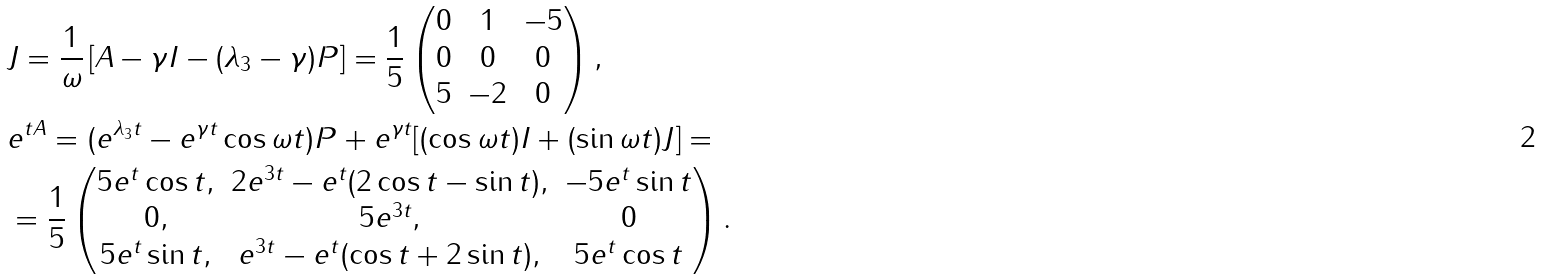<formula> <loc_0><loc_0><loc_500><loc_500>& J = \frac { 1 } { \omega } \left [ A - \gamma I - ( \lambda _ { 3 } - \gamma ) P \right ] = \frac { 1 } { 5 } \begin{pmatrix} 0 & 1 & - 5 \\ 0 & 0 & 0 \\ 5 & - 2 & 0 \end{pmatrix} , \\ & e ^ { t A } = ( e ^ { \lambda _ { 3 } t } - e ^ { \gamma t } \cos { \omega t } ) P + e ^ { \gamma t } [ ( \cos { \omega t } ) I + ( \sin { \omega t } ) J ] = \\ & = \frac { 1 } { 5 } \begin{pmatrix} 5 e ^ { t } \cos { t } , & 2 e ^ { 3 t } - e ^ { t } ( 2 \cos { t } - \sin { t } ) , & - 5 e ^ { t } \sin { t } \\ 0 , & 5 e ^ { 3 t } , & 0 \\ 5 e ^ { t } \sin { t } , & e ^ { 3 t } - e ^ { t } ( \cos { t } + 2 \sin { t } ) , & 5 e ^ { t } \cos { t } \end{pmatrix} .</formula> 